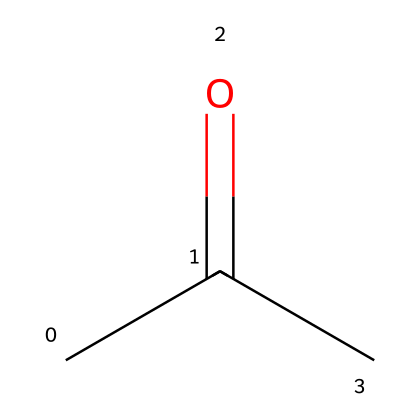How many carbon atoms are in acetone? The SMILES representation "CC(=O)C" shows a total of three carbon atoms: two carbon atoms in the chain and one carbon in the carbonyl group (C=O).
Answer: three What type of functional group is present in acetone? In the SMILES structure "CC(=O)C", the carbon atom double-bonded to an oxygen (C=O) indicates the presence of a ketone functional group.
Answer: ketone How many hydrogen atoms are in acetone? From the SMILES representation "CC(=O)C", we can deduce the number of hydrogen atoms by counting: each carbon (C) is generally tetravalent. The middle carbon has one hydrogen, and each of the end carbons has three, leading to a total of six hydrogen atoms.
Answer: six What is the degree of unsaturation in acetone? The degree of unsaturation can be calculated by identifying the number of rings and π bonds. In acetone, there is one double bond (C=O), which contributes one to the degree of unsaturation. Therefore, the degree of unsaturation is one.
Answer: one Is acetone a polar or nonpolar solvent? Acetone contains a polar carbonyl group (C=O), making the overall molecule polar, so it is classified as a polar solvent.
Answer: polar What is the molecular formula of acetone? From the SMILES "CC(=O)C", we can derive the molecular formula by counting the atoms: three carbons (C3), six hydrogens (H6), and one oxygen (O), leading to the formula C3H6O.
Answer: C3H6O 